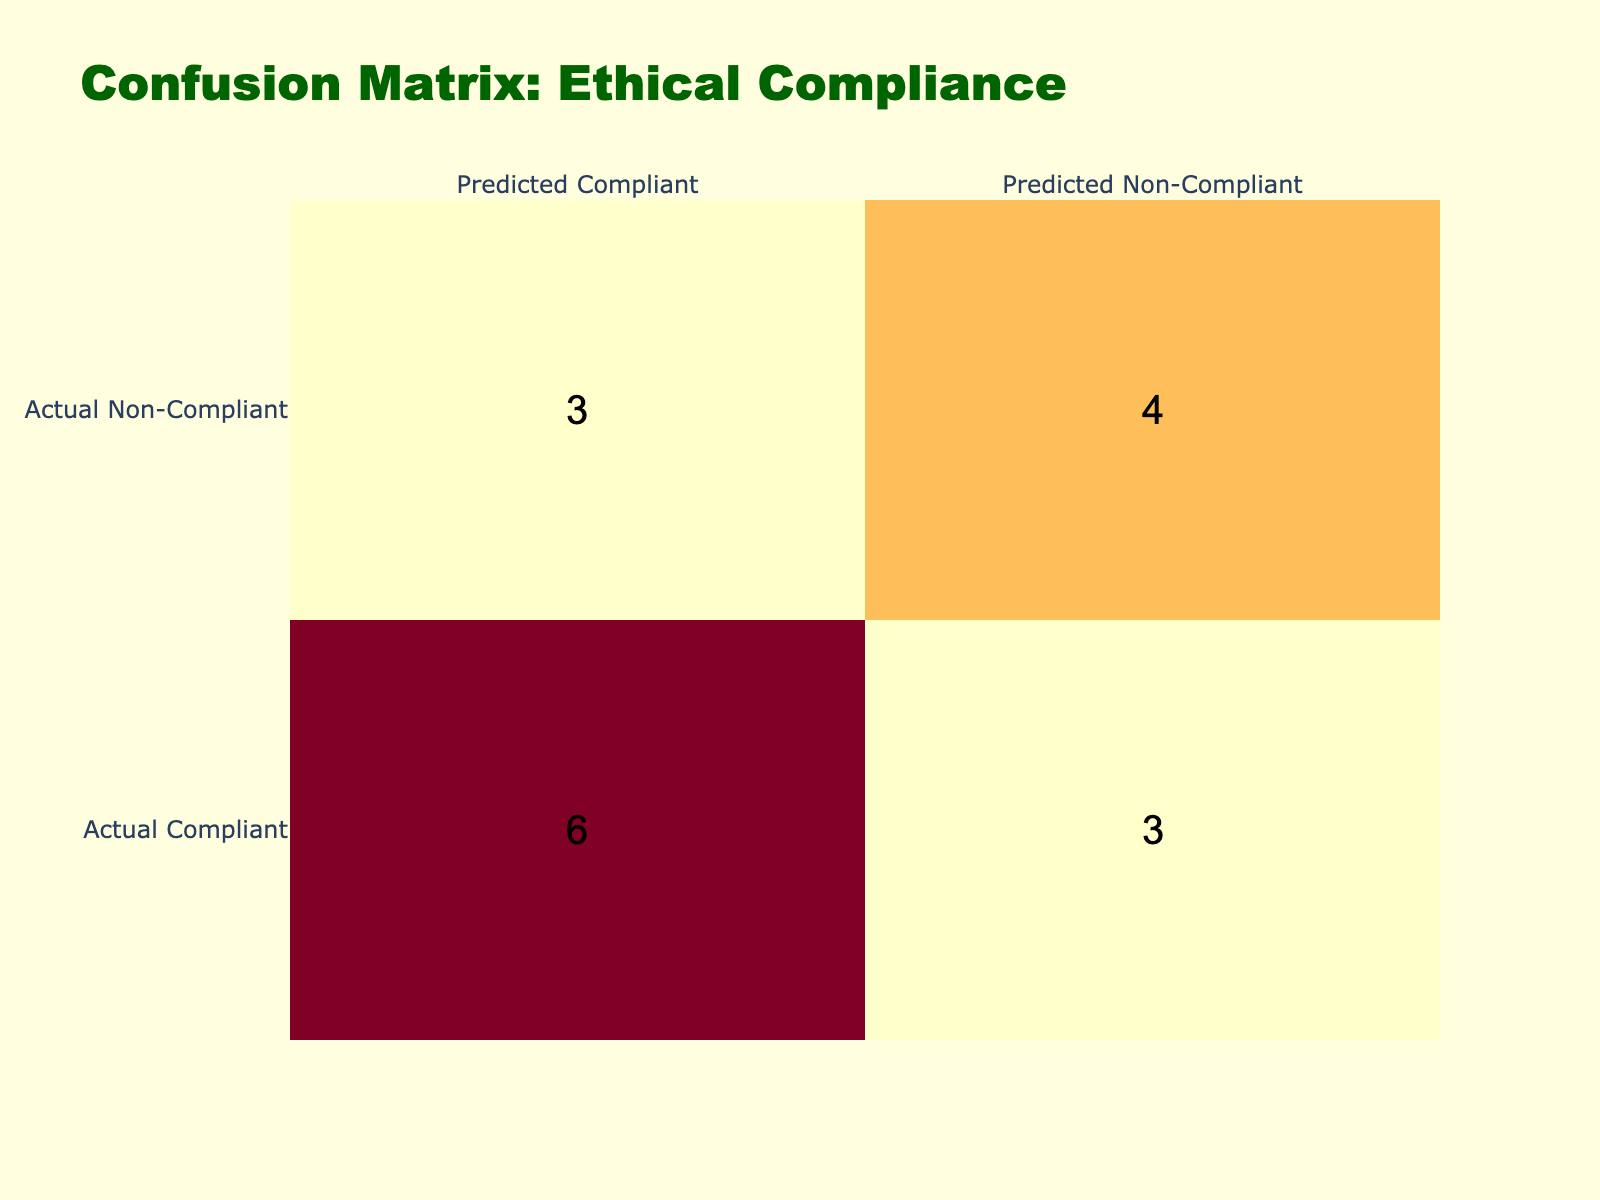What is the number of businesses that were correctly predicted as compliant? To find this number, look at the cell where both actual and predicted compliance are "Compliant." In the matrix, this is represented with the value corresponding to "Actual Compliant" and "Predicted Compliant." The value in this cell is 7.
Answer: 7 How many businesses were incorrectly predicted as non-compliant? This can be determined by checking the cell where actual compliance is "Compliant" and predicted compliance is "Non-Compliant." In the table, this value is 4.
Answer: 4 What is the total number of non-compliant businesses? To find this, sum the values in the row corresponding to "Actual Non-Compliant." The values in this row are 3 (Predicted Compliant) and 4 (Predicted Non-Compliant), which adds up to 7.
Answer: 7 Is the number of compliant businesses correctly predicted higher than the number of non-compliant businesses correctly predicted? The correctly predicted compliant businesses are 7, while non-compliant correctly predicted businesses are 3. Since 7 is greater than 3, the statement is true.
Answer: Yes What is the discrepancy between the predicted compliant and predicted non-compliant businesses? The predicted compliant businesses total to 7 (3 from non-compliant row and 7 from compliant row) while non-compliant businesses predicted is 4. The discrepancy is 7 - 4 = 3.
Answer: 3 How many businesses were correctly classified as non-compliant? The cell where both actual and predicted compliance are "Non-Compliant" gives this information. The corresponding value is 3 in the table.
Answer: 3 What is the percentage of businesses that were correctly predicted as compliant out of the total businesses? The total number of businesses is 16. The correctly predicted as compliant is 7, so (7/16) * 100 = 43.75%.
Answer: 43.75% Did more businesses end up being incorrectly predicted as compliant than as non-compliant? The incorrectly predicted compliant businesses (actual non-compliant predicted compliant) total 3, and the incorrectly predicted non-compliant businesses (actual compliant predicted non-compliant) total 4. Since 3 is less than 4, the statement is false.
Answer: No What is the ratio of compliant to non-compliant predictions? The number of compliant predictions is 7 (predicted compliant) and non-compliant predictions is 4. Therefore, the ratio is 7:4.
Answer: 7:4 